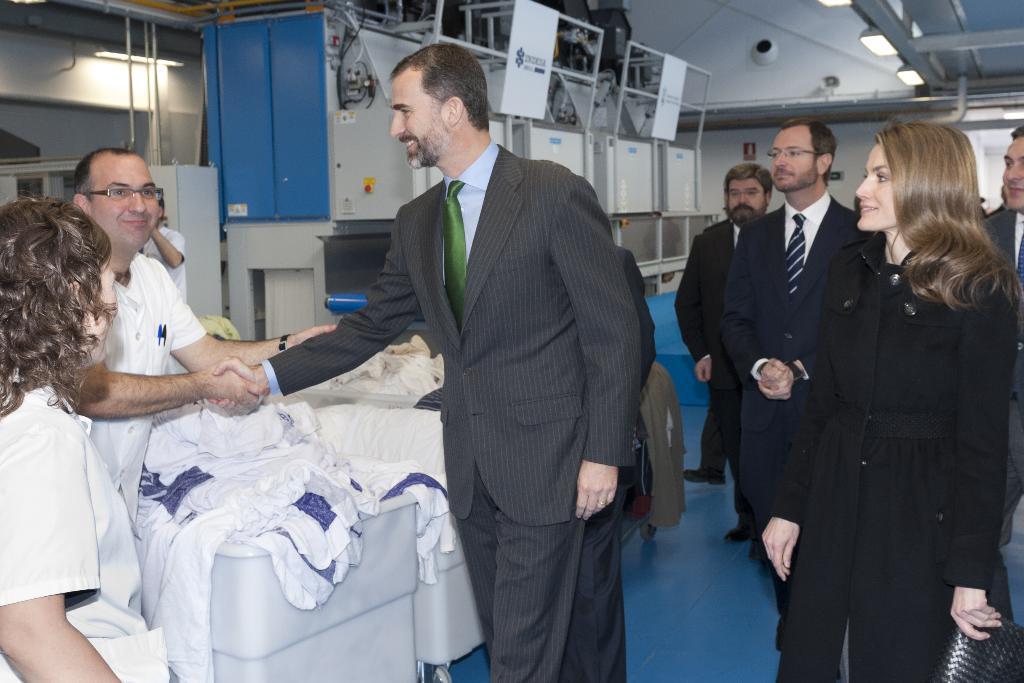Describe this image in one or two sentences. There are group of people standing. I can see two men hand shaking and smiling. I think these are the clothes. These look like the machines. These are the lights, which are attached to the roof. 